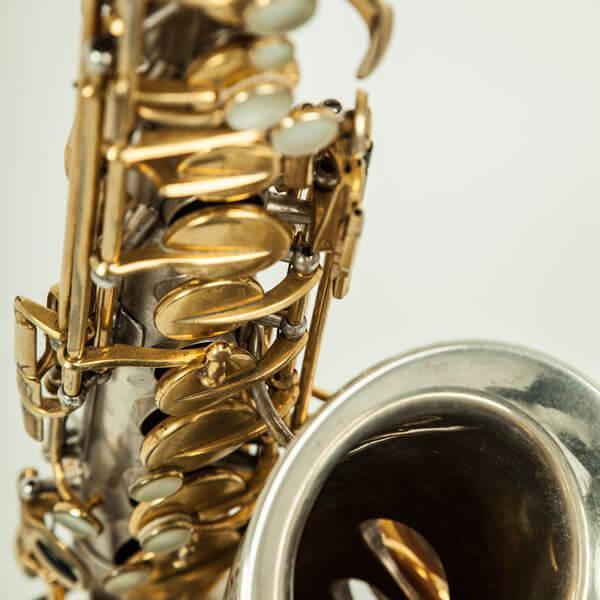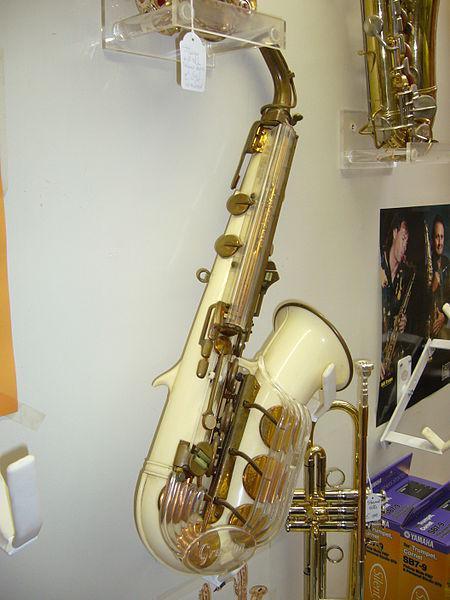The first image is the image on the left, the second image is the image on the right. For the images displayed, is the sentence "In at least on image there is a brass saxophone facing left with it black case behind it." factually correct? Answer yes or no. No. The first image is the image on the left, the second image is the image on the right. Assess this claim about the two images: "In the image on the right, one of the saxophones is sitting next to a closed case, while the other saxophone is sitting inside an open case.". Correct or not? Answer yes or no. No. 